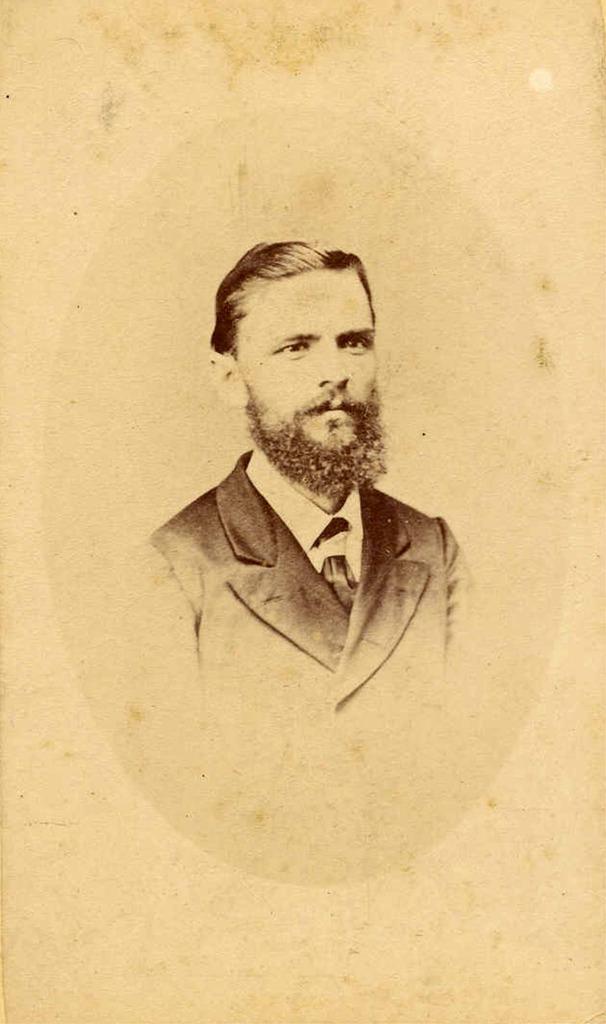Can you describe this image briefly? In this image I see the depiction of a man and I see that the man is wearing a suit, shirt and a tie. 